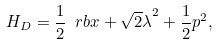<formula> <loc_0><loc_0><loc_500><loc_500>H _ { D } = \frac { 1 } { 2 } \ r b { x + \sqrt { 2 } \lambda } ^ { 2 } + \frac { 1 } { 2 } p ^ { 2 } ,</formula> 